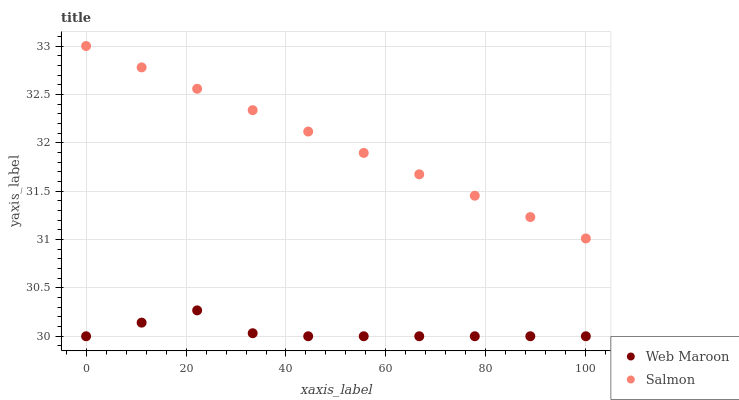Does Web Maroon have the minimum area under the curve?
Answer yes or no. Yes. Does Salmon have the maximum area under the curve?
Answer yes or no. Yes. Does Web Maroon have the maximum area under the curve?
Answer yes or no. No. Is Salmon the smoothest?
Answer yes or no. Yes. Is Web Maroon the roughest?
Answer yes or no. Yes. Is Web Maroon the smoothest?
Answer yes or no. No. Does Web Maroon have the lowest value?
Answer yes or no. Yes. Does Salmon have the highest value?
Answer yes or no. Yes. Does Web Maroon have the highest value?
Answer yes or no. No. Is Web Maroon less than Salmon?
Answer yes or no. Yes. Is Salmon greater than Web Maroon?
Answer yes or no. Yes. Does Web Maroon intersect Salmon?
Answer yes or no. No. 